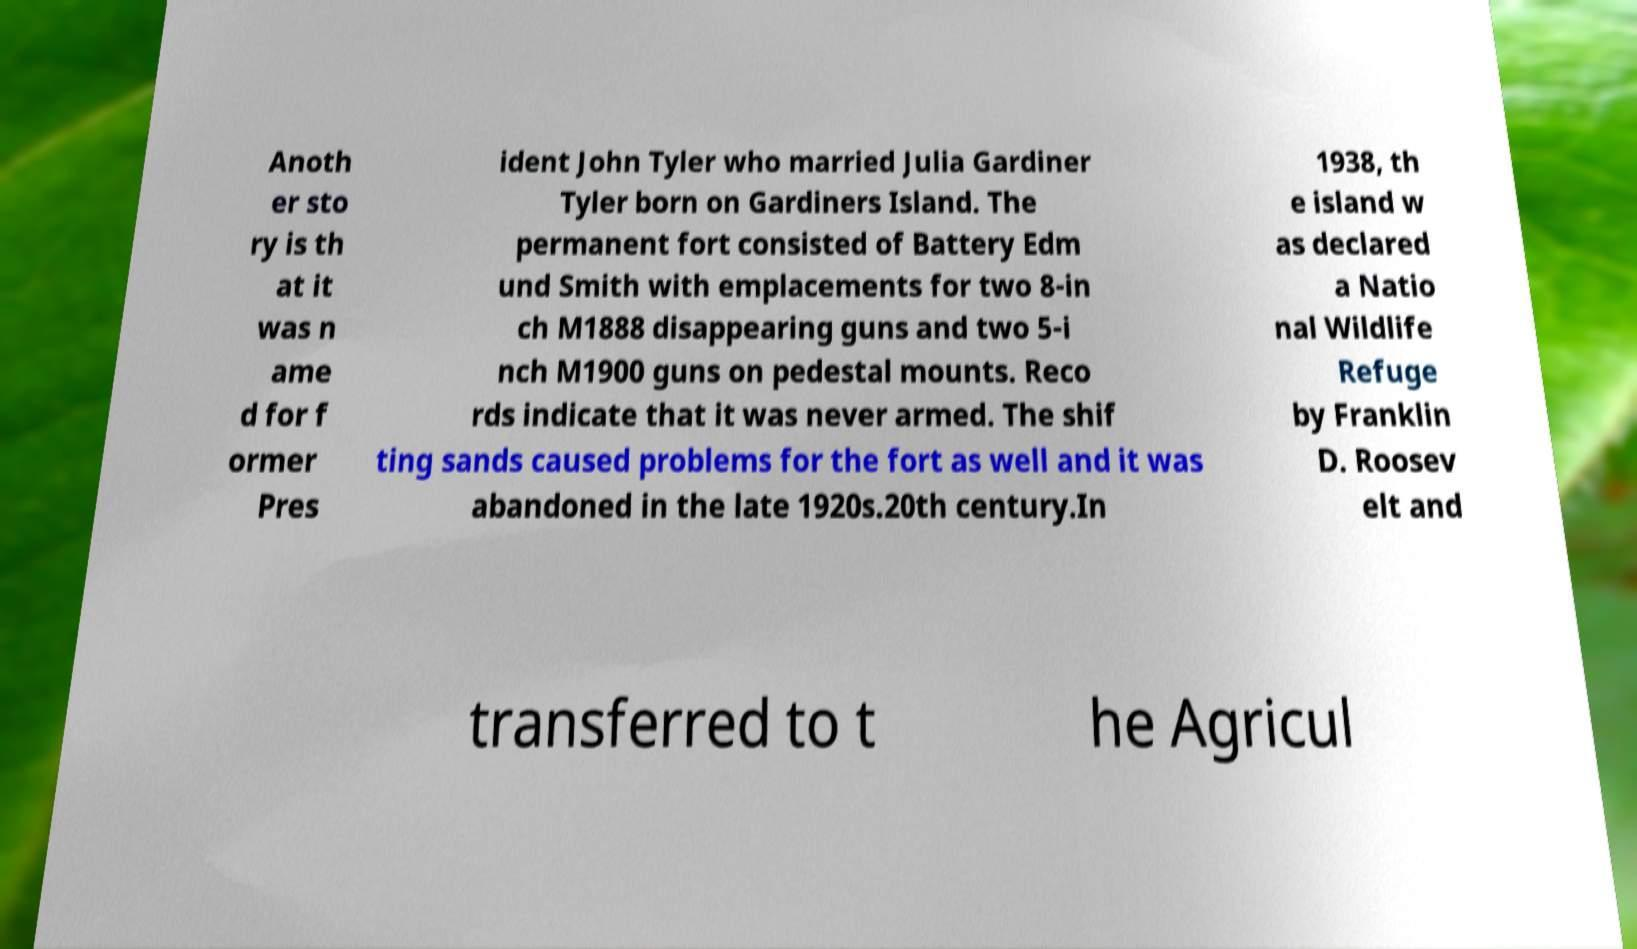Please identify and transcribe the text found in this image. Anoth er sto ry is th at it was n ame d for f ormer Pres ident John Tyler who married Julia Gardiner Tyler born on Gardiners Island. The permanent fort consisted of Battery Edm und Smith with emplacements for two 8-in ch M1888 disappearing guns and two 5-i nch M1900 guns on pedestal mounts. Reco rds indicate that it was never armed. The shif ting sands caused problems for the fort as well and it was abandoned in the late 1920s.20th century.In 1938, th e island w as declared a Natio nal Wildlife Refuge by Franklin D. Roosev elt and transferred to t he Agricul 